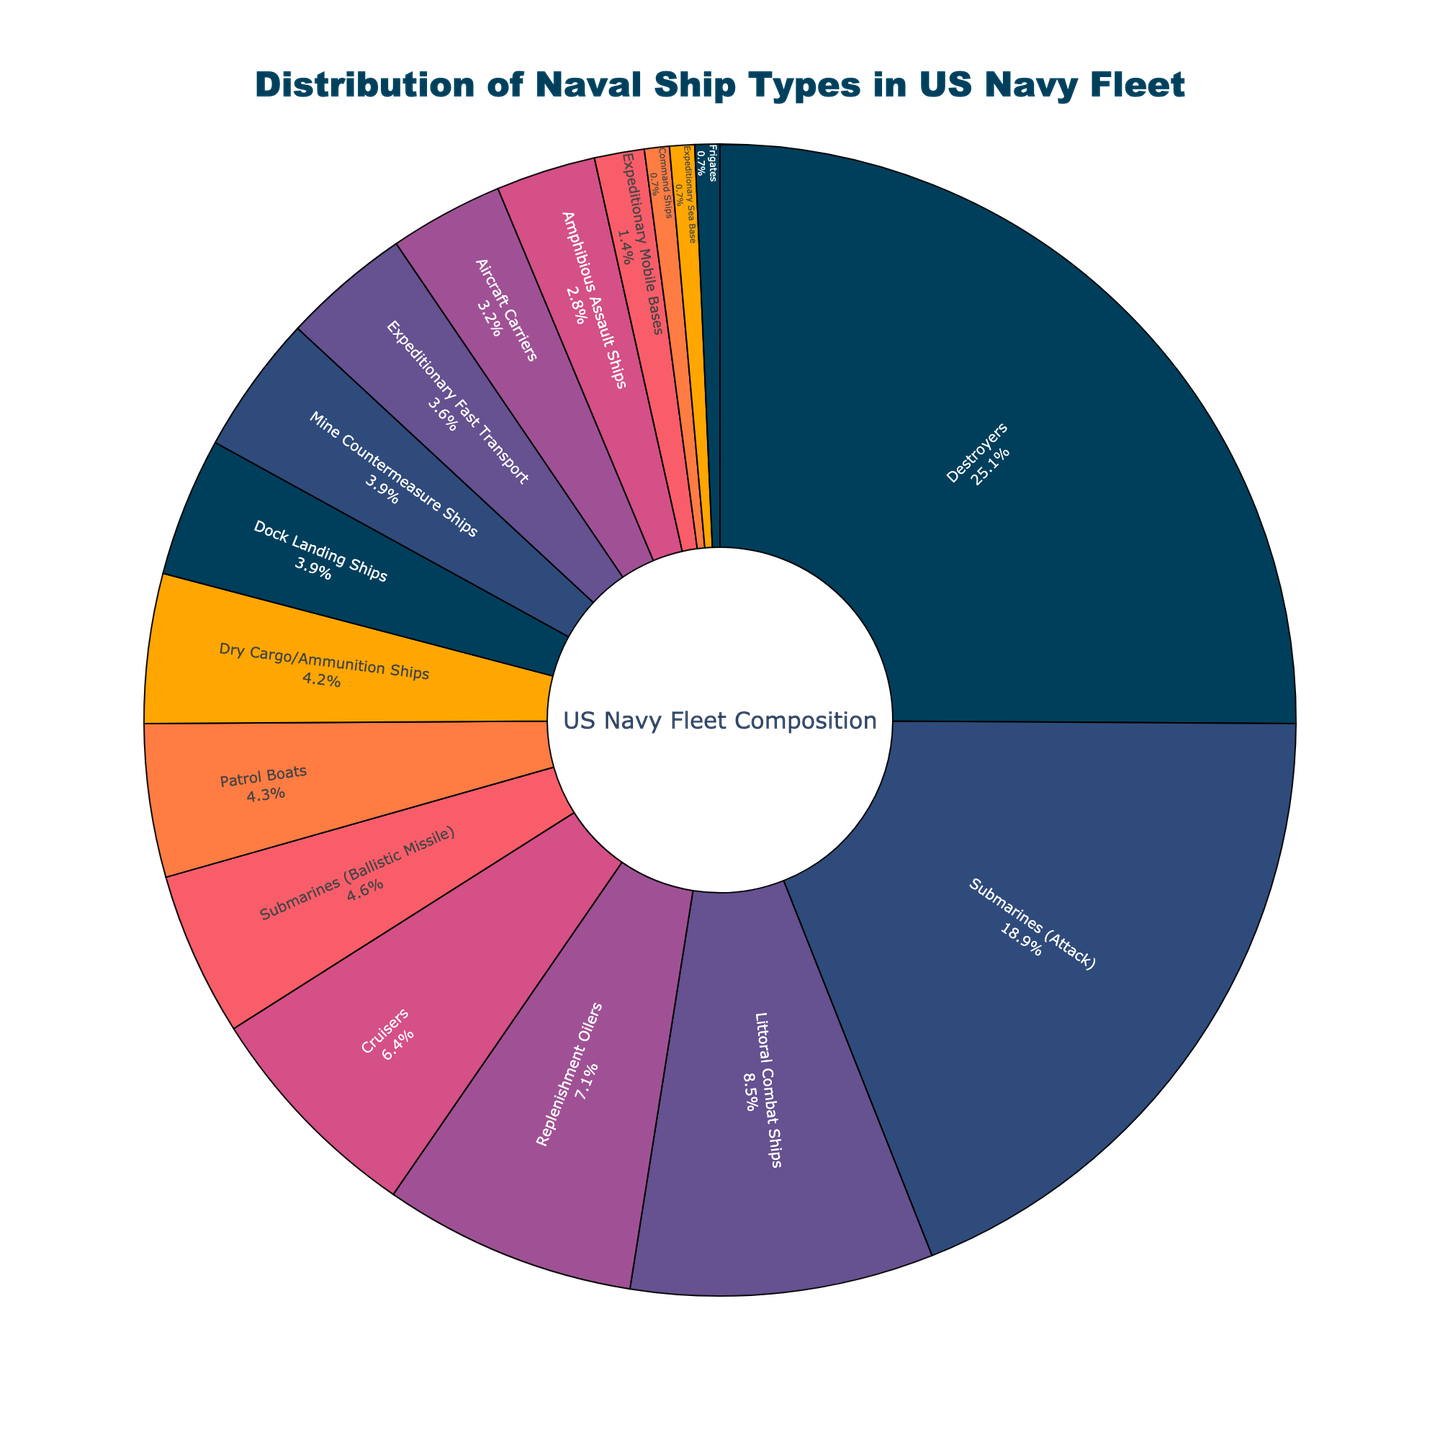Which ship type has the highest percentage in the US Navy fleet? Looking at the pie chart, the ship type with the largest section will have the highest percentage.
Answer: Destroyers What is the combined percentage of all submarine types in the US Navy fleet? Add the percentages of Attack Submarines (18.9%) and Ballistic Missile Submarines (4.6%). 18.9 + 4.6 = 23.5
Answer: 23.5 Are there more Aircraft Carriers or Mine Countermeasure Ships in the fleet, and by how much? Compare the percentages: Aircraft Carriers (3.2%) and Mine Countermeasure Ships (3.9%). Subtract the smaller percentage from the larger. 3.9 - 3.2 = 0.7
Answer: Mine Countermeasure Ships by 0.7% Which ship type occupies the smallest proportion of the fleet, and what is its percentage? Find the ship type with the smallest section in the pie chart and identify its percentage.
Answer: Frigates, Command Ships, and Expeditionary Sea Base all have 0.7% What is the difference in the percentage between Destroyers and Replenishment Oilers? The percentages of Destroyers (25.1%) and Replenishment Oilers (7.1%) are given. Subtract the smaller percentage from the larger. 25.1 - 7.1 = 18
Answer: 18 What proportion of the fleet do Command Ships, Frigates, and Expeditionary Sea Base make up together? Sum the percentages of Command Ships (0.7%), Frigates (0.7%), and Expeditionary Sea Base (0.7%). 0.7 + 0.7 + 0.7 = 2.1
Answer: 2.1 Which ship types have a percentage between 3% and 5% in the fleet? Identify ship types with percentages between 3% and 5% from the chart: Aircraft Carriers (3.2%), Amphibious Assault Ships (2.8% - ignore), Mine Countermeasure Ships (3.9%), Dock Landing Ships (3.9%), and Dry Cargo/Ammunition Ships (4.2%).
Answer: Aircraft Carriers, Mine Countermeasure Ships, Dock Landing Ships, Dry Cargo/Ammunition Ships Are there more Littoral Combat Ships or Cruisers, and by how much? Compare the percentages: Littoral Combat Ships (8.5%) and Cruisers (6.4%). Subtract the smaller percentage from the larger. 8.5 - 6.4 = 2.1
Answer: Littoral Combat Ships by 2.1% What is the average percentage of the four most predominant ship types in the fleet? Identify the top four ship types by percentage: Destroyers (25.1%), Attack Submarines (18.9%), Littoral Combat Ships (8.5%), and Replenishment Oilers (7.1%). Calculate the average. (25.1 + 18.9 + 8.5 + 7.1) / 4 = 14.9
Answer: 14.9 How much more percentage of the fleet do Destroyers take up compared to Command Ships? The percentages of Destroyers (25.1%) and Command Ships (0.7%) are given. Subtract the smaller percentage from the larger. 25.1 - 0.7 = 24.4
Answer: 24.4 